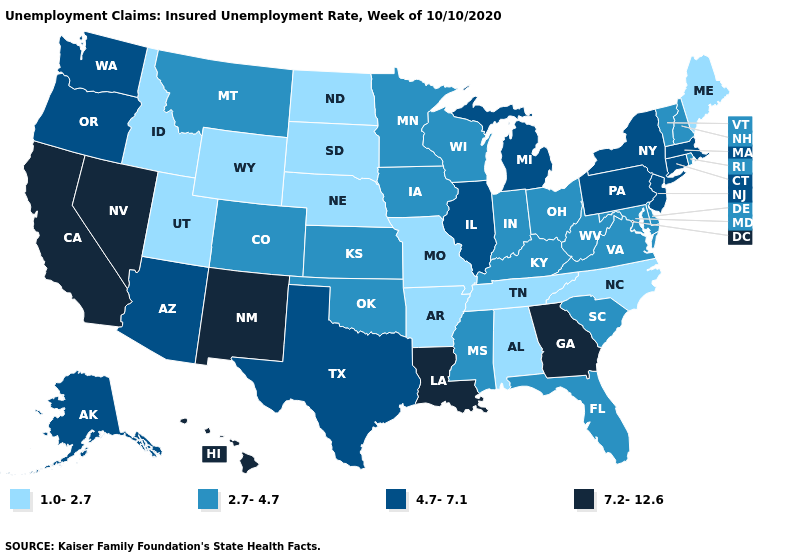Does Alaska have the same value as New York?
Quick response, please. Yes. What is the value of New York?
Keep it brief. 4.7-7.1. Name the states that have a value in the range 7.2-12.6?
Keep it brief. California, Georgia, Hawaii, Louisiana, Nevada, New Mexico. What is the value of South Carolina?
Give a very brief answer. 2.7-4.7. Among the states that border Delaware , does Maryland have the highest value?
Answer briefly. No. Among the states that border Connecticut , does Rhode Island have the lowest value?
Give a very brief answer. Yes. Does Wyoming have the same value as New Hampshire?
Be succinct. No. Which states have the highest value in the USA?
Short answer required. California, Georgia, Hawaii, Louisiana, Nevada, New Mexico. What is the value of Pennsylvania?
Answer briefly. 4.7-7.1. Which states have the highest value in the USA?
Short answer required. California, Georgia, Hawaii, Louisiana, Nevada, New Mexico. What is the lowest value in the USA?
Quick response, please. 1.0-2.7. What is the value of Oregon?
Concise answer only. 4.7-7.1. Name the states that have a value in the range 4.7-7.1?
Give a very brief answer. Alaska, Arizona, Connecticut, Illinois, Massachusetts, Michigan, New Jersey, New York, Oregon, Pennsylvania, Texas, Washington. Does the map have missing data?
Short answer required. No. 